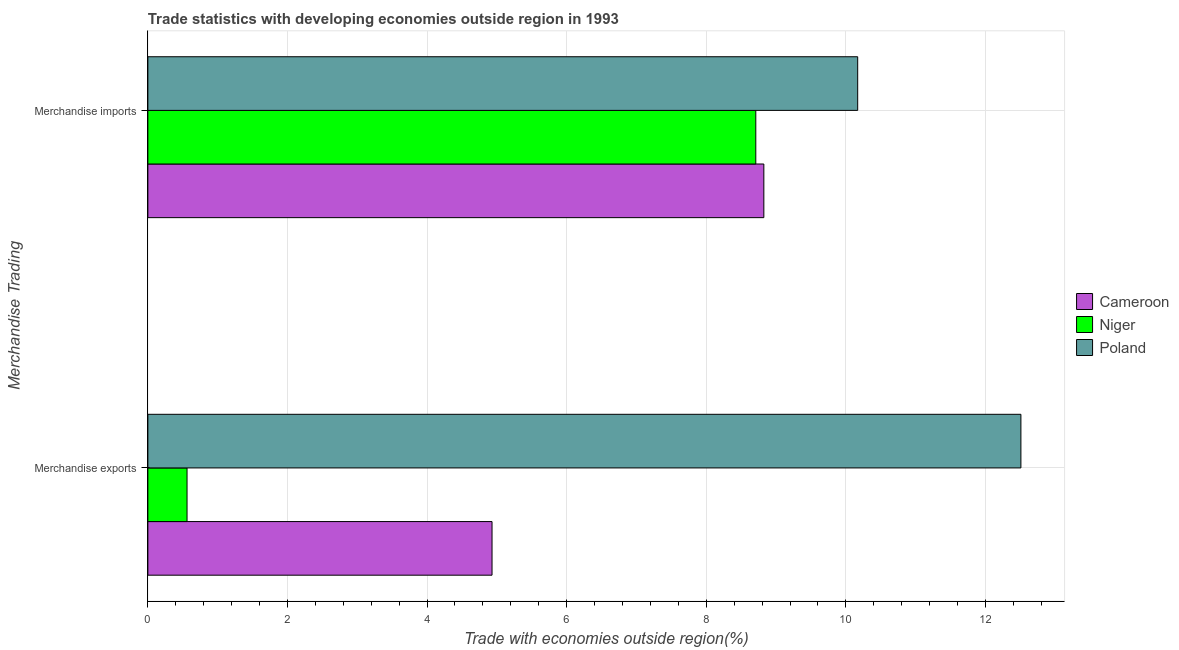How many groups of bars are there?
Your answer should be very brief. 2. Are the number of bars per tick equal to the number of legend labels?
Your answer should be very brief. Yes. Are the number of bars on each tick of the Y-axis equal?
Your answer should be compact. Yes. How many bars are there on the 2nd tick from the bottom?
Ensure brevity in your answer.  3. What is the label of the 2nd group of bars from the top?
Your answer should be compact. Merchandise exports. What is the merchandise imports in Cameroon?
Provide a short and direct response. 8.83. Across all countries, what is the maximum merchandise imports?
Keep it short and to the point. 10.17. Across all countries, what is the minimum merchandise exports?
Your response must be concise. 0.56. In which country was the merchandise exports minimum?
Your answer should be very brief. Niger. What is the total merchandise imports in the graph?
Make the answer very short. 27.71. What is the difference between the merchandise exports in Niger and that in Poland?
Offer a very short reply. -11.95. What is the difference between the merchandise imports in Poland and the merchandise exports in Niger?
Provide a short and direct response. 9.61. What is the average merchandise exports per country?
Your answer should be very brief. 6. What is the difference between the merchandise imports and merchandise exports in Cameroon?
Provide a succinct answer. 3.89. What is the ratio of the merchandise exports in Cameroon to that in Poland?
Your response must be concise. 0.39. Is the merchandise exports in Poland less than that in Cameroon?
Give a very brief answer. No. What does the 3rd bar from the top in Merchandise imports represents?
Give a very brief answer. Cameroon. What does the 3rd bar from the bottom in Merchandise imports represents?
Your answer should be very brief. Poland. How many bars are there?
Provide a succinct answer. 6. How many countries are there in the graph?
Your answer should be very brief. 3. Does the graph contain grids?
Offer a very short reply. Yes. Where does the legend appear in the graph?
Ensure brevity in your answer.  Center right. How many legend labels are there?
Your answer should be very brief. 3. What is the title of the graph?
Keep it short and to the point. Trade statistics with developing economies outside region in 1993. Does "Nigeria" appear as one of the legend labels in the graph?
Offer a terse response. No. What is the label or title of the X-axis?
Your answer should be compact. Trade with economies outside region(%). What is the label or title of the Y-axis?
Your response must be concise. Merchandise Trading. What is the Trade with economies outside region(%) in Cameroon in Merchandise exports?
Keep it short and to the point. 4.93. What is the Trade with economies outside region(%) of Niger in Merchandise exports?
Give a very brief answer. 0.56. What is the Trade with economies outside region(%) in Poland in Merchandise exports?
Give a very brief answer. 12.51. What is the Trade with economies outside region(%) of Cameroon in Merchandise imports?
Your answer should be very brief. 8.83. What is the Trade with economies outside region(%) in Niger in Merchandise imports?
Make the answer very short. 8.71. What is the Trade with economies outside region(%) in Poland in Merchandise imports?
Ensure brevity in your answer.  10.17. Across all Merchandise Trading, what is the maximum Trade with economies outside region(%) of Cameroon?
Your answer should be very brief. 8.83. Across all Merchandise Trading, what is the maximum Trade with economies outside region(%) of Niger?
Your answer should be compact. 8.71. Across all Merchandise Trading, what is the maximum Trade with economies outside region(%) of Poland?
Keep it short and to the point. 12.51. Across all Merchandise Trading, what is the minimum Trade with economies outside region(%) in Cameroon?
Keep it short and to the point. 4.93. Across all Merchandise Trading, what is the minimum Trade with economies outside region(%) in Niger?
Ensure brevity in your answer.  0.56. Across all Merchandise Trading, what is the minimum Trade with economies outside region(%) of Poland?
Offer a terse response. 10.17. What is the total Trade with economies outside region(%) of Cameroon in the graph?
Give a very brief answer. 13.76. What is the total Trade with economies outside region(%) of Niger in the graph?
Ensure brevity in your answer.  9.27. What is the total Trade with economies outside region(%) in Poland in the graph?
Provide a short and direct response. 22.68. What is the difference between the Trade with economies outside region(%) of Cameroon in Merchandise exports and that in Merchandise imports?
Give a very brief answer. -3.89. What is the difference between the Trade with economies outside region(%) in Niger in Merchandise exports and that in Merchandise imports?
Keep it short and to the point. -8.15. What is the difference between the Trade with economies outside region(%) of Poland in Merchandise exports and that in Merchandise imports?
Your answer should be compact. 2.34. What is the difference between the Trade with economies outside region(%) in Cameroon in Merchandise exports and the Trade with economies outside region(%) in Niger in Merchandise imports?
Keep it short and to the point. -3.78. What is the difference between the Trade with economies outside region(%) of Cameroon in Merchandise exports and the Trade with economies outside region(%) of Poland in Merchandise imports?
Your answer should be compact. -5.24. What is the difference between the Trade with economies outside region(%) of Niger in Merchandise exports and the Trade with economies outside region(%) of Poland in Merchandise imports?
Provide a succinct answer. -9.61. What is the average Trade with economies outside region(%) in Cameroon per Merchandise Trading?
Give a very brief answer. 6.88. What is the average Trade with economies outside region(%) of Niger per Merchandise Trading?
Your answer should be very brief. 4.64. What is the average Trade with economies outside region(%) in Poland per Merchandise Trading?
Your answer should be very brief. 11.34. What is the difference between the Trade with economies outside region(%) in Cameroon and Trade with economies outside region(%) in Niger in Merchandise exports?
Provide a succinct answer. 4.37. What is the difference between the Trade with economies outside region(%) of Cameroon and Trade with economies outside region(%) of Poland in Merchandise exports?
Your answer should be compact. -7.58. What is the difference between the Trade with economies outside region(%) of Niger and Trade with economies outside region(%) of Poland in Merchandise exports?
Provide a short and direct response. -11.95. What is the difference between the Trade with economies outside region(%) in Cameroon and Trade with economies outside region(%) in Niger in Merchandise imports?
Offer a terse response. 0.12. What is the difference between the Trade with economies outside region(%) of Cameroon and Trade with economies outside region(%) of Poland in Merchandise imports?
Make the answer very short. -1.34. What is the difference between the Trade with economies outside region(%) of Niger and Trade with economies outside region(%) of Poland in Merchandise imports?
Your response must be concise. -1.46. What is the ratio of the Trade with economies outside region(%) of Cameroon in Merchandise exports to that in Merchandise imports?
Keep it short and to the point. 0.56. What is the ratio of the Trade with economies outside region(%) in Niger in Merchandise exports to that in Merchandise imports?
Provide a succinct answer. 0.06. What is the ratio of the Trade with economies outside region(%) of Poland in Merchandise exports to that in Merchandise imports?
Ensure brevity in your answer.  1.23. What is the difference between the highest and the second highest Trade with economies outside region(%) of Cameroon?
Provide a short and direct response. 3.89. What is the difference between the highest and the second highest Trade with economies outside region(%) of Niger?
Give a very brief answer. 8.15. What is the difference between the highest and the second highest Trade with economies outside region(%) in Poland?
Provide a short and direct response. 2.34. What is the difference between the highest and the lowest Trade with economies outside region(%) of Cameroon?
Provide a short and direct response. 3.89. What is the difference between the highest and the lowest Trade with economies outside region(%) in Niger?
Provide a short and direct response. 8.15. What is the difference between the highest and the lowest Trade with economies outside region(%) in Poland?
Give a very brief answer. 2.34. 